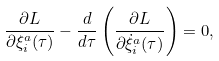<formula> <loc_0><loc_0><loc_500><loc_500>\frac { \partial L } { \partial \xi ^ { a } _ { i } ( \tau ) } - \frac { d } { d \tau } \left ( \frac { \partial L } { \partial \dot { \xi } ^ { a } _ { i } ( \tau ) } \right ) = 0 ,</formula> 